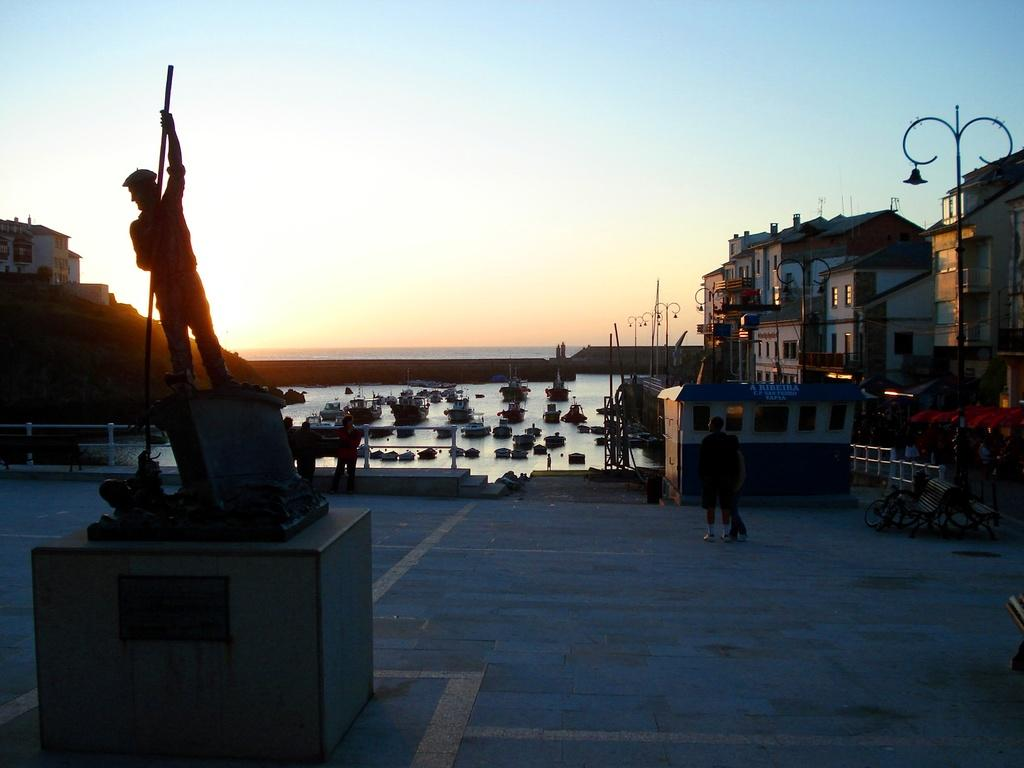What is located in the left corner of the image? There is a statue of a person holding a stick in the left corner of the image. What can be seen behind the statue? There are boats on the water behind the statue. What is visible in the right corner of the image? There are buildings in the right corner of the image. What is the mind of the person holding the stick in the image thinking? The image does not provide any information about the thoughts or mind of the person holding the stick, as it is a statue and not a living person. Who is the manager of the boats on the water in the image? The image does not provide any information about the management or personnel of the boats on the water. 